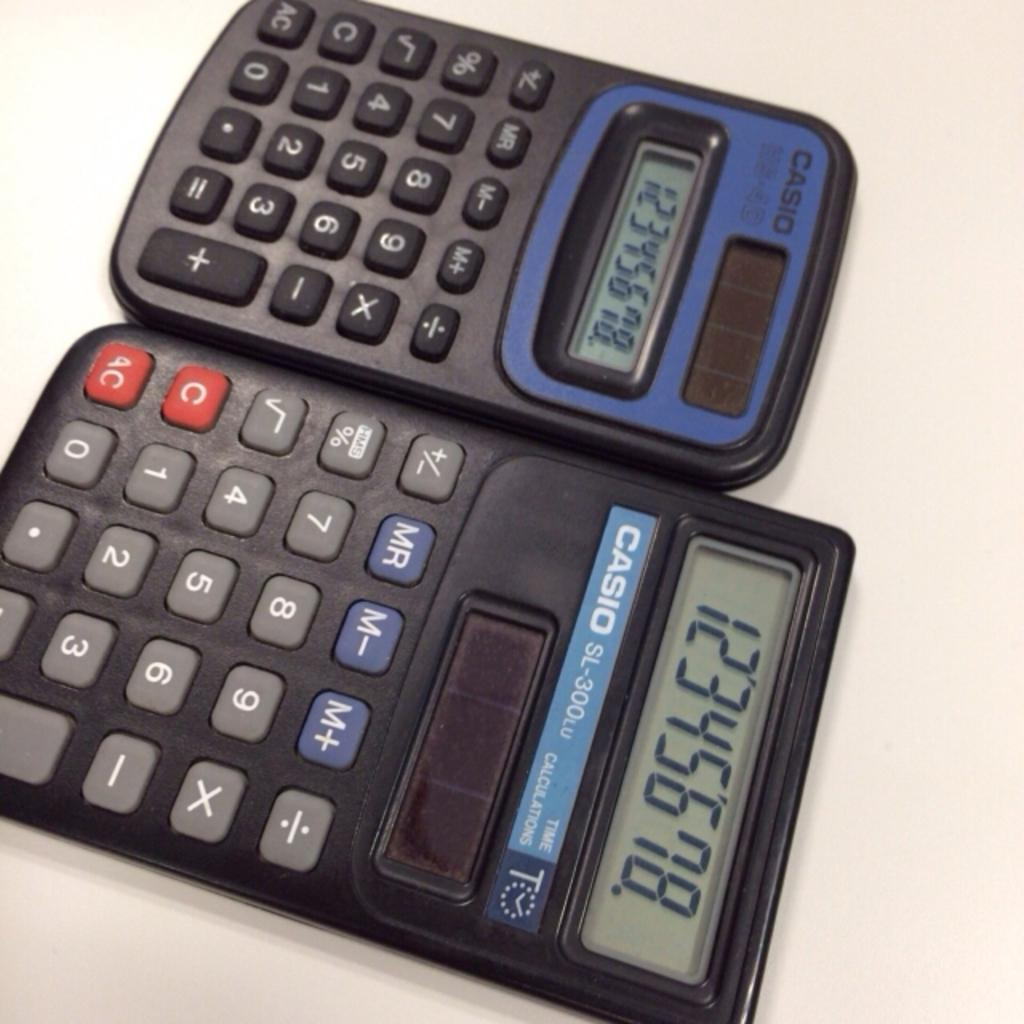<image>
Summarize the visual content of the image. Two Casio calculators with numbers displayed on their screens. 